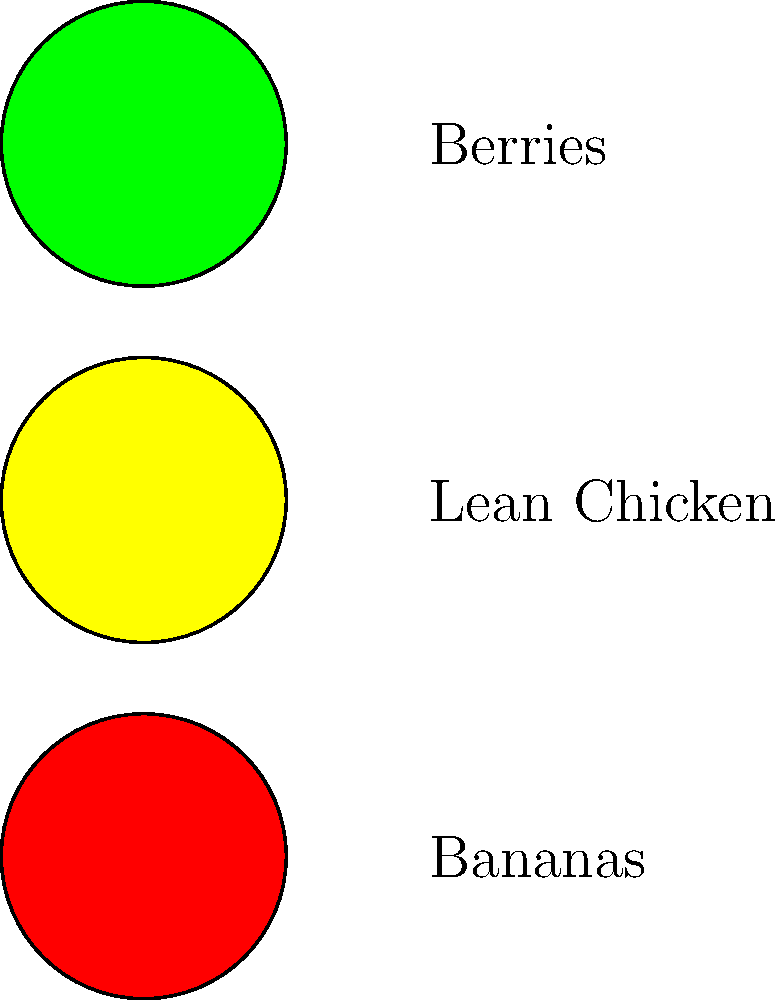Based on the traffic light color-coded chart for kidney-friendly foods, which item should be consumed with caution by dialysis patients? Let's analyze the traffic light color-coded chart for kidney-friendly foods:

1. Green light (top): Berries
   - Green indicates foods that are generally safe and beneficial for kidney health.
   - Berries are low in potassium and high in antioxidants, making them a good choice for dialysis patients.

2. Yellow light (middle): Lean Chicken
   - Yellow suggests foods that should be consumed in moderation or with caution.
   - Lean chicken is a good source of protein, which is important for dialysis patients. However, it should be consumed in controlled portions due to its phosphorus content.

3. Red light (bottom): Bananas
   - Red signifies foods that should be avoided or severely limited in a kidney-friendly diet.
   - Bananas are high in potassium, which can be dangerous for dialysis patients as their kidneys cannot efficiently remove excess potassium from the blood.

Based on this analysis, the item that should be consumed with caution (yellow light) is lean chicken. While it provides necessary protein, dialysis patients need to be mindful of portion sizes due to its phosphorus content.
Answer: Lean Chicken 